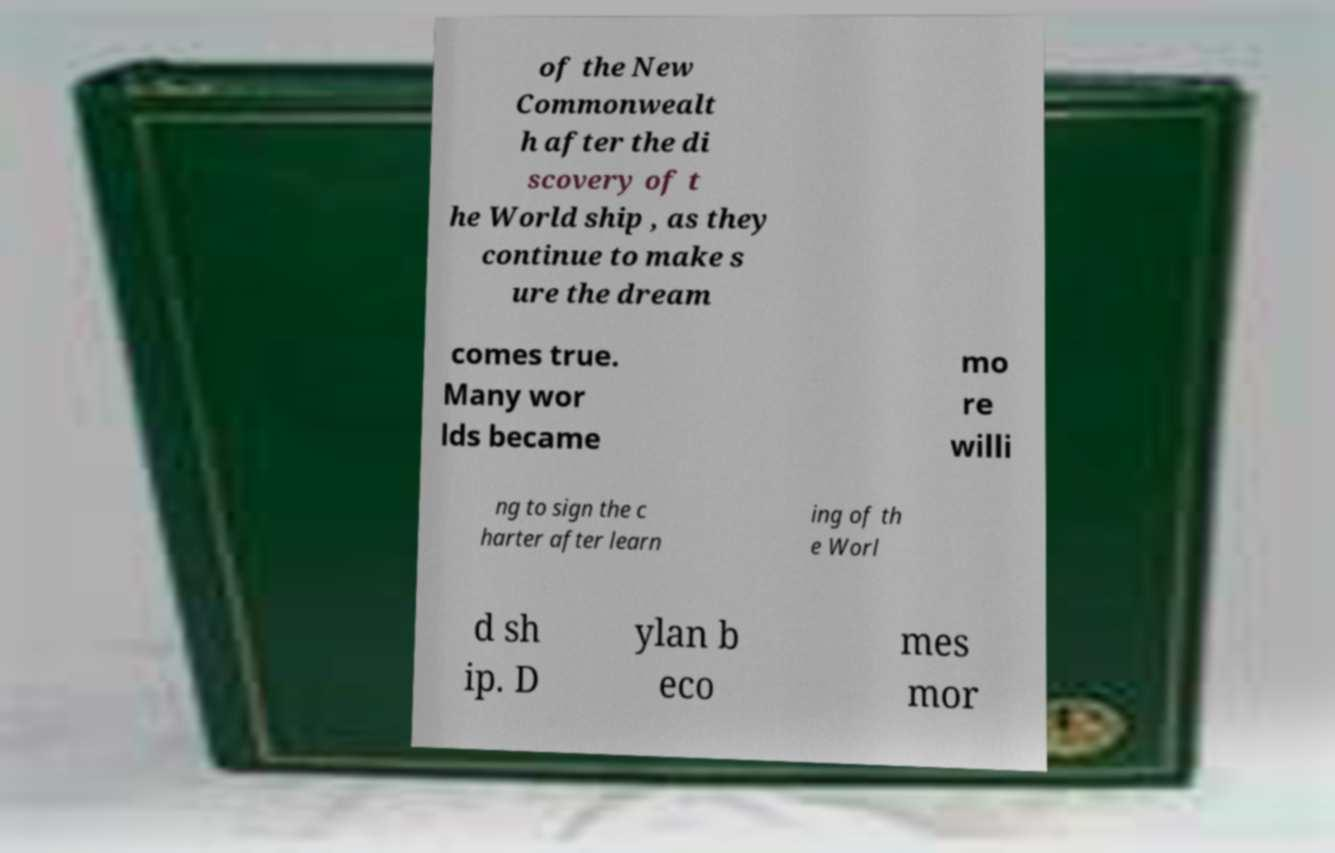Can you read and provide the text displayed in the image?This photo seems to have some interesting text. Can you extract and type it out for me? of the New Commonwealt h after the di scovery of t he World ship , as they continue to make s ure the dream comes true. Many wor lds became mo re willi ng to sign the c harter after learn ing of th e Worl d sh ip. D ylan b eco mes mor 